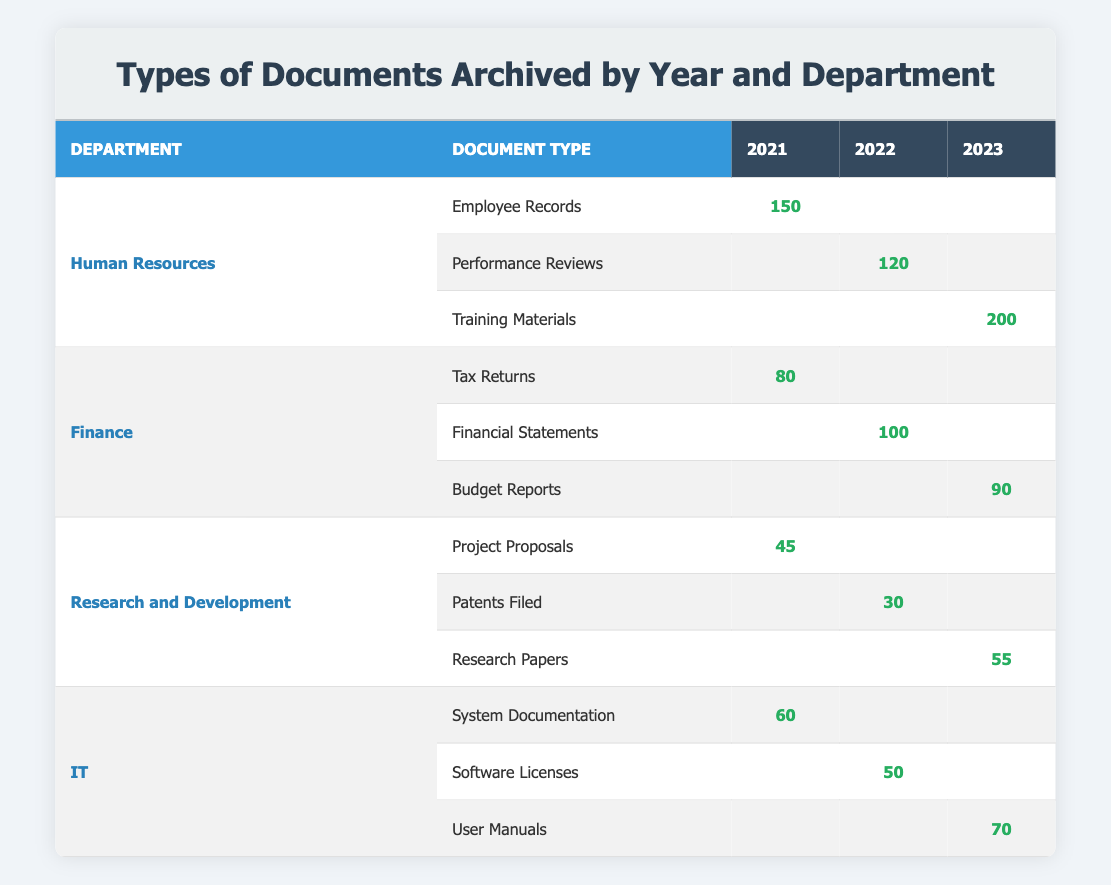What is the total number of documents archived in the Human Resources department in 2021? In 2021, the Human Resources department archived 150 Employee Records. The values of the other years for this department are not required for this calculation. Therefore, the total number of documents for 2021 is 150.
Answer: 150 How many different types of documents were archived by the Finance department across the three years? The Finance department has three types of documents archived: Tax Returns (2021), Financial Statements (2022), and Budget Reports (2023). Therefore, the total count of different types of documents archived by Finance is 3.
Answer: 3 What is the count of the documents archived in the IT department in 2023? In 2023, the IT department archived 70 User Manuals. The count for this specific year is 70.
Answer: 70 Is there a document type archived by the Research and Development department each year? The Research and Development department archived Project Proposals in 2021, Patents Filed in 2022, and Research Papers in 2023. Since there is a document type for each year, the answer is yes.
Answer: Yes What is the average number of documents archived by the Finance department over the three years? The counts for the Finance department are: 80 in 2021, 100 in 2022, and 90 in 2023. To find the average, sum these counts: 80 + 100 + 90 = 270. Then divide by the number of years (3): 270 / 3 = 90.
Answer: 90 Which department archived the highest number of documents in 2023? In 2023, the counts for each department are: Human Resources (200), Finance (90), Research and Development (55), and IT (70). The maximum count is from the Human Resources department, which archived 200 documents.
Answer: Human Resources What is the cumulative count of documents archived by the Research and Development department over the three years? The counts for the Research and Development department are: 45 in 2021, 30 in 2022, and 55 in 2023. To find the cumulative count, sum these values: 45 + 30 + 55 = 130.
Answer: 130 Did the number of archived documents for Human Resources increase from 2022 to 2023? In 2022, Human Resources archived 120 Performance Reviews, and in 2023, they archived 200 Training Materials. Since 200 is greater than 120, the number increased.
Answer: Yes What is the difference in the count of documents archived by the IT department between 2021 and 2022? The IT department archived 60 System Documentation in 2021 and 50 Software Licenses in 2022. The difference can be calculated by taking the counts: 60 - 50 = 10.
Answer: 10 